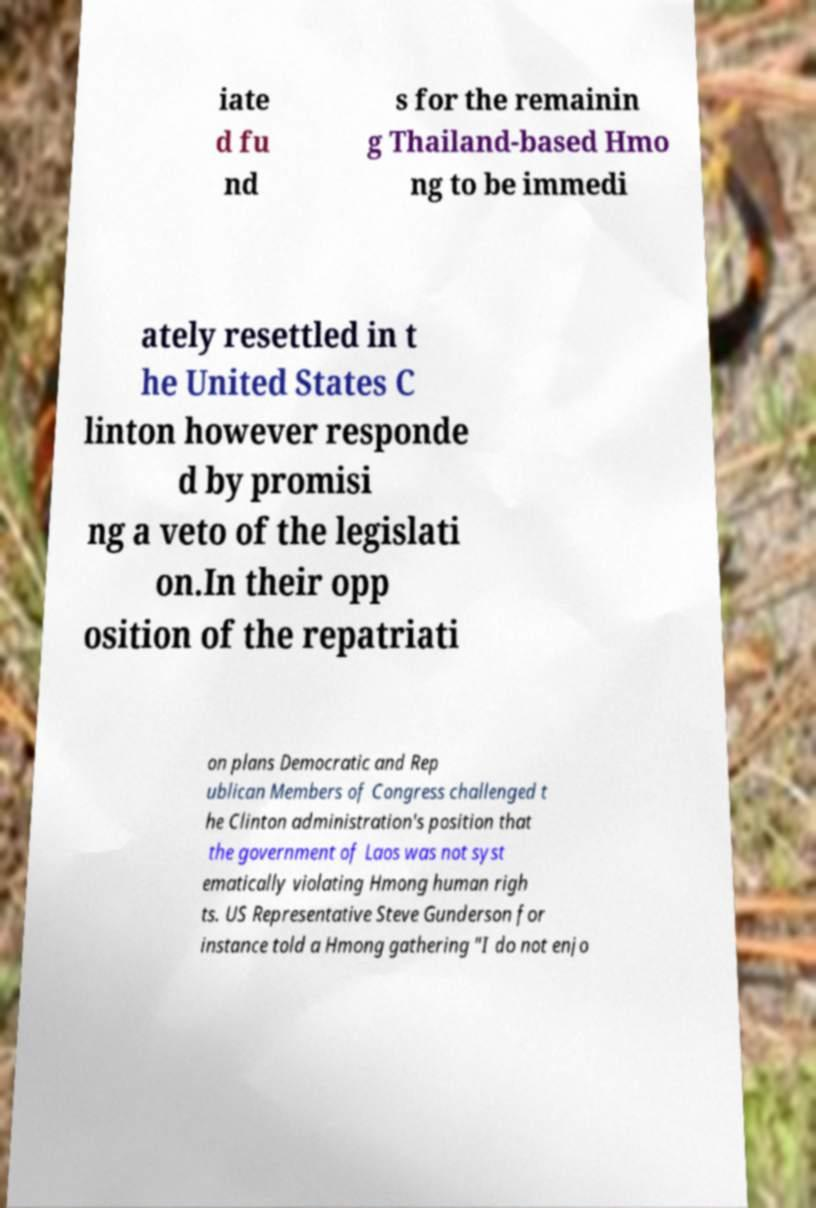Can you accurately transcribe the text from the provided image for me? iate d fu nd s for the remainin g Thailand-based Hmo ng to be immedi ately resettled in t he United States C linton however responde d by promisi ng a veto of the legislati on.In their opp osition of the repatriati on plans Democratic and Rep ublican Members of Congress challenged t he Clinton administration's position that the government of Laos was not syst ematically violating Hmong human righ ts. US Representative Steve Gunderson for instance told a Hmong gathering "I do not enjo 